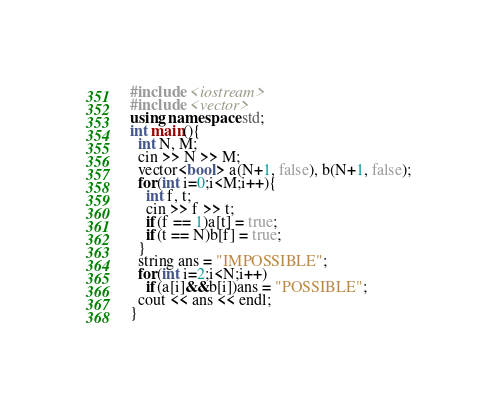<code> <loc_0><loc_0><loc_500><loc_500><_C++_>#include <iostream>
#include <vector>
using namespace std;
int main(){
  int N, M;
  cin >> N >> M;
  vector<bool> a(N+1, false), b(N+1, false);
  for(int i=0;i<M;i++){
    int f, t;
    cin >> f >> t;
    if(f == 1)a[t] = true;
    if(t == N)b[f] = true;
  }
  string ans = "IMPOSSIBLE";
  for(int i=2;i<N;i++)
    if(a[i]&&b[i])ans = "POSSIBLE";
  cout << ans << endl;
}
</code> 